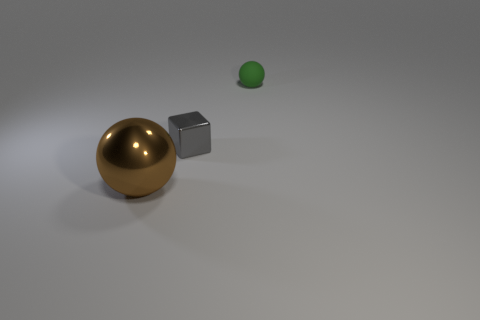There is a sphere that is to the right of the small object that is on the left side of the matte ball; what number of green matte balls are in front of it?
Keep it short and to the point. 0. Is there anything else that is the same shape as the gray shiny thing?
Make the answer very short. No. How many objects are either spheres in front of the gray cube or gray metallic blocks?
Offer a very short reply. 2. There is a small thing that is to the left of the sphere to the right of the small gray metallic cube; what shape is it?
Provide a short and direct response. Cube. Are there fewer big brown shiny balls that are on the right side of the small rubber object than balls that are on the right side of the brown metal object?
Make the answer very short. Yes. There is a matte thing that is the same shape as the brown metal thing; what is its size?
Provide a succinct answer. Small. Is there anything else that has the same size as the brown thing?
Provide a short and direct response. No. How many things are either objects that are in front of the small shiny cube or objects that are on the right side of the brown metallic thing?
Give a very brief answer. 3. Is the gray block the same size as the matte ball?
Ensure brevity in your answer.  Yes. Are there more gray metal blocks than small purple cylinders?
Ensure brevity in your answer.  Yes. 